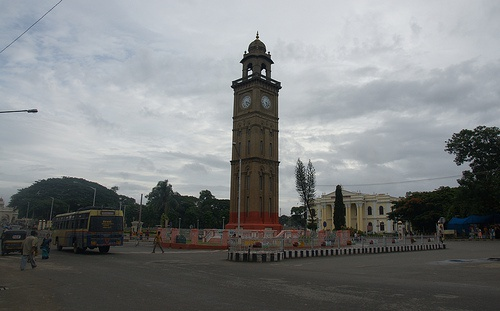Describe the objects in this image and their specific colors. I can see bus in darkgray, black, darkgreen, and gray tones, people in darkgray, black, gray, and maroon tones, people in darkgray, black, and gray tones, people in darkgray and black tones, and people in darkgray, black, maroon, and gray tones in this image. 